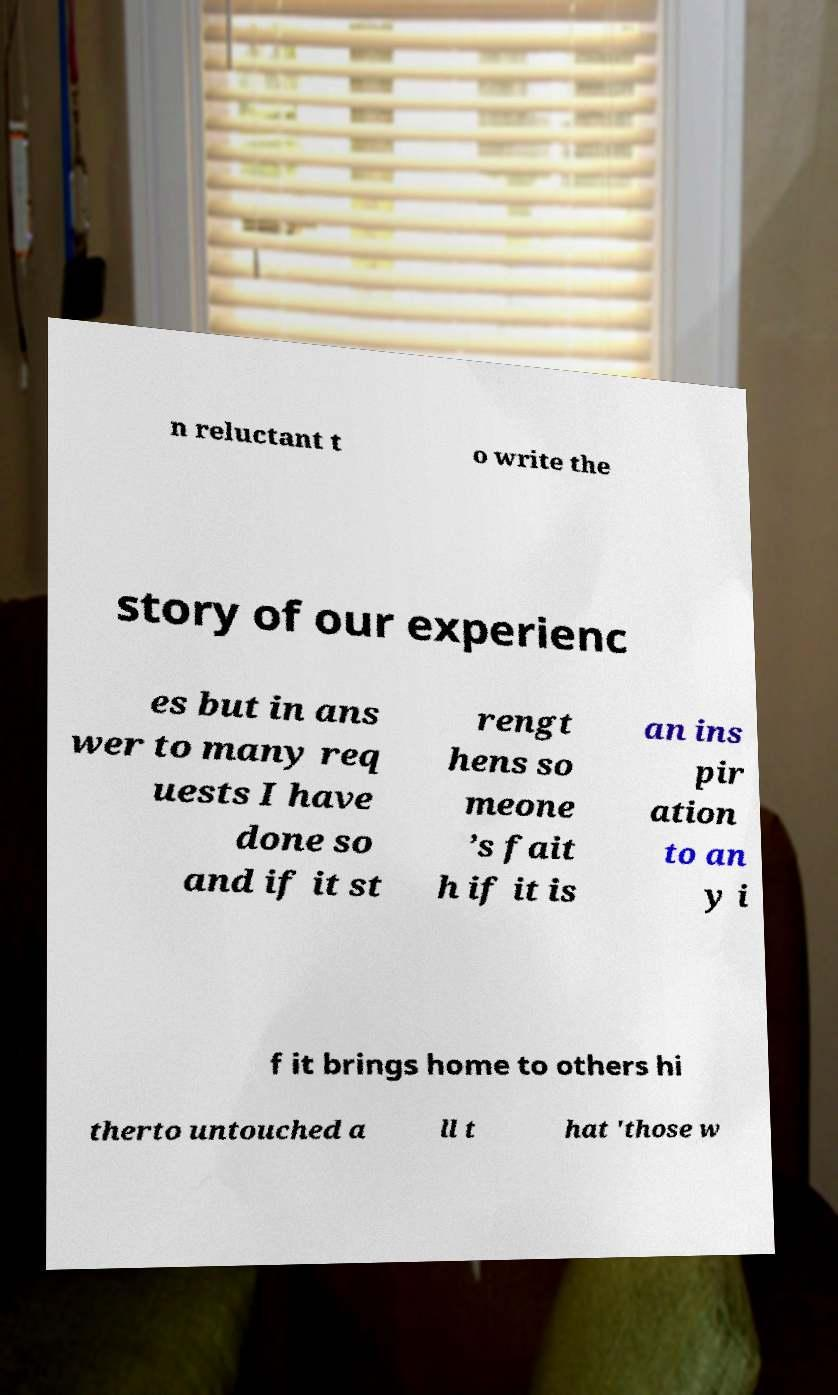Can you accurately transcribe the text from the provided image for me? n reluctant t o write the story of our experienc es but in ans wer to many req uests I have done so and if it st rengt hens so meone ’s fait h if it is an ins pir ation to an y i f it brings home to others hi therto untouched a ll t hat 'those w 